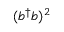<formula> <loc_0><loc_0><loc_500><loc_500>( b ^ { \dagger } b ) ^ { 2 }</formula> 